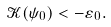<formula> <loc_0><loc_0><loc_500><loc_500>\mathcal { K } ( \psi _ { 0 } ) < - \varepsilon _ { 0 } .</formula> 